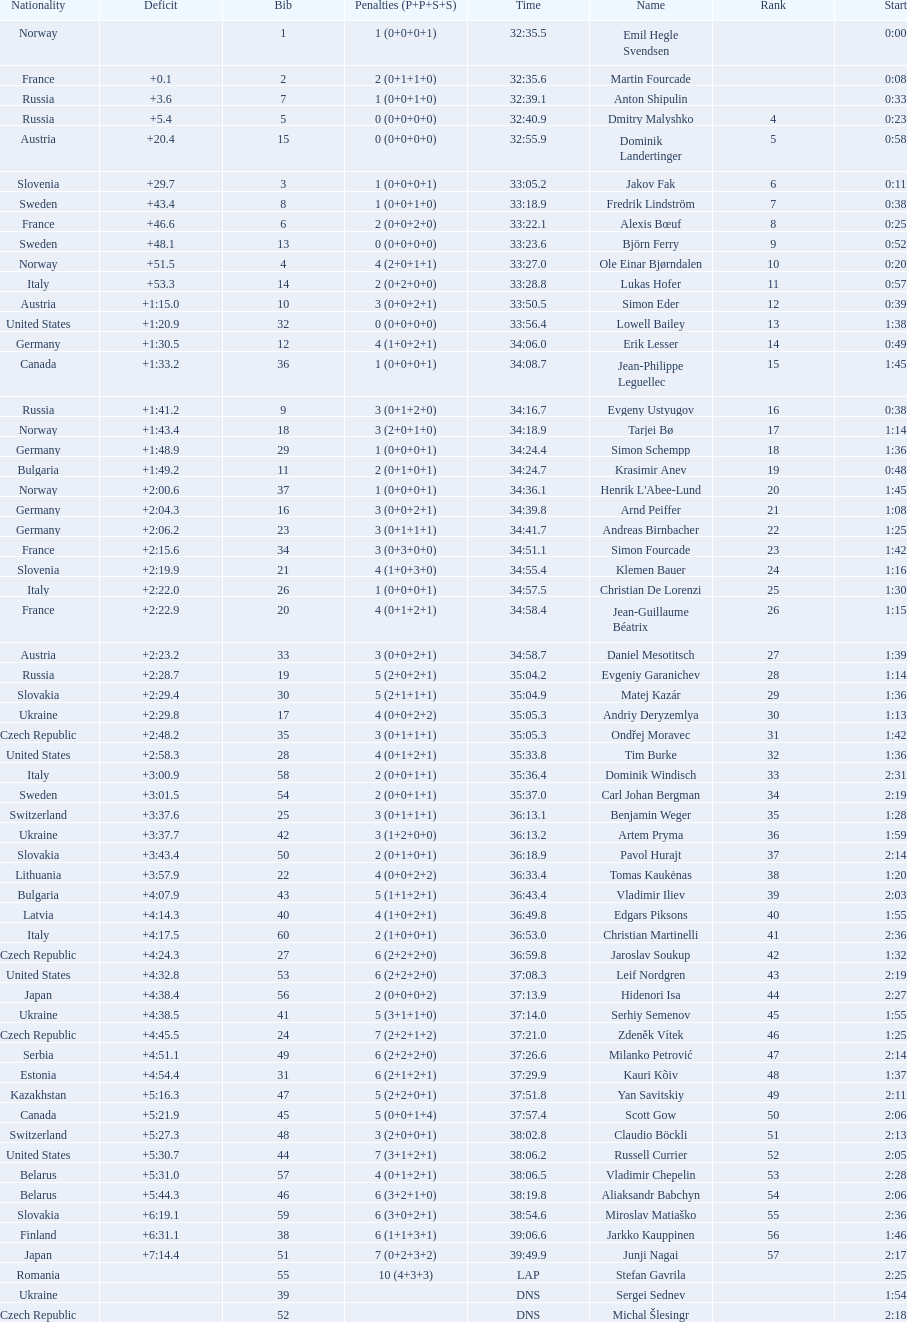How many took at least 35:00 to finish? 30. 